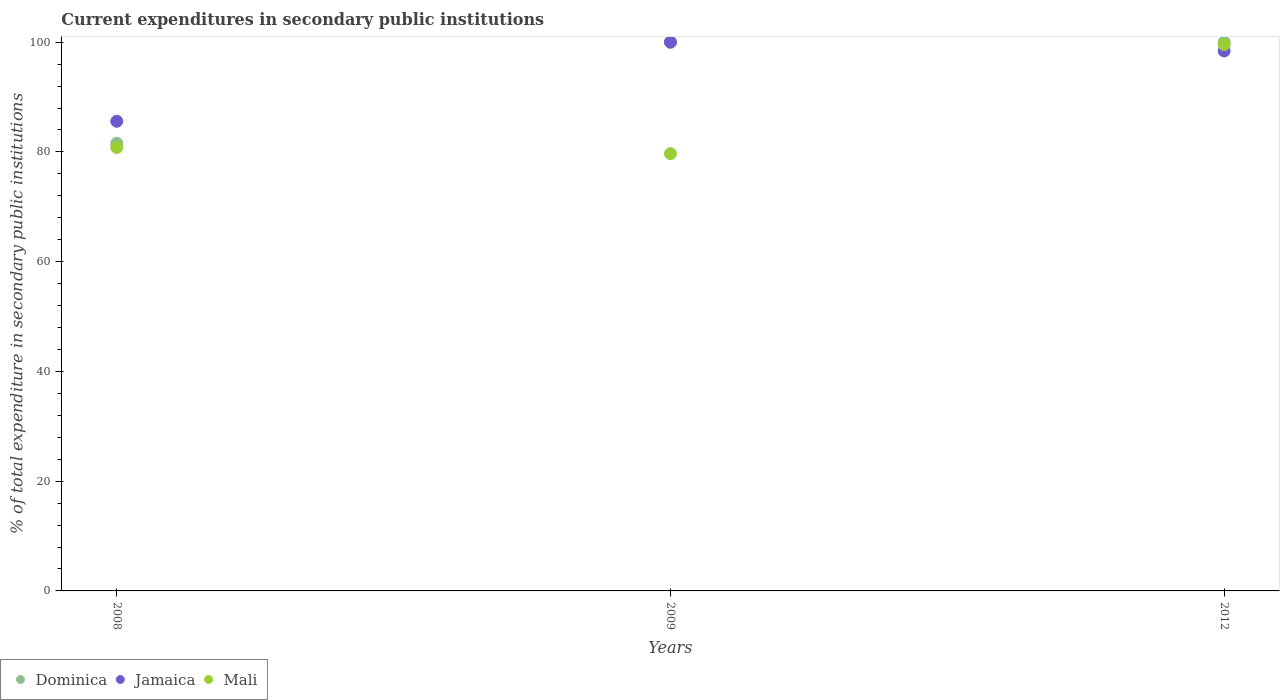What is the current expenditures in secondary public institutions in Jamaica in 2012?
Ensure brevity in your answer.  98.4. Across all years, what is the maximum current expenditures in secondary public institutions in Jamaica?
Ensure brevity in your answer.  100. Across all years, what is the minimum current expenditures in secondary public institutions in Jamaica?
Ensure brevity in your answer.  85.58. In which year was the current expenditures in secondary public institutions in Dominica maximum?
Offer a terse response. 2009. In which year was the current expenditures in secondary public institutions in Dominica minimum?
Offer a very short reply. 2008. What is the total current expenditures in secondary public institutions in Dominica in the graph?
Your answer should be very brief. 281.58. What is the difference between the current expenditures in secondary public institutions in Jamaica in 2008 and that in 2012?
Make the answer very short. -12.81. What is the difference between the current expenditures in secondary public institutions in Jamaica in 2012 and the current expenditures in secondary public institutions in Dominica in 2009?
Give a very brief answer. -1.6. What is the average current expenditures in secondary public institutions in Dominica per year?
Keep it short and to the point. 93.86. In the year 2008, what is the difference between the current expenditures in secondary public institutions in Mali and current expenditures in secondary public institutions in Dominica?
Provide a succinct answer. -0.77. What is the ratio of the current expenditures in secondary public institutions in Dominica in 2008 to that in 2012?
Keep it short and to the point. 0.82. Is the current expenditures in secondary public institutions in Mali in 2008 less than that in 2012?
Offer a terse response. Yes. What is the difference between the highest and the second highest current expenditures in secondary public institutions in Mali?
Provide a short and direct response. 18.75. What is the difference between the highest and the lowest current expenditures in secondary public institutions in Mali?
Make the answer very short. 19.87. Is the sum of the current expenditures in secondary public institutions in Jamaica in 2008 and 2012 greater than the maximum current expenditures in secondary public institutions in Dominica across all years?
Ensure brevity in your answer.  Yes. Is the current expenditures in secondary public institutions in Jamaica strictly greater than the current expenditures in secondary public institutions in Mali over the years?
Offer a very short reply. No. How many dotlines are there?
Your answer should be very brief. 3. How many years are there in the graph?
Your answer should be very brief. 3. Are the values on the major ticks of Y-axis written in scientific E-notation?
Ensure brevity in your answer.  No. Does the graph contain any zero values?
Offer a very short reply. No. Where does the legend appear in the graph?
Give a very brief answer. Bottom left. How are the legend labels stacked?
Offer a terse response. Horizontal. What is the title of the graph?
Provide a short and direct response. Current expenditures in secondary public institutions. Does "High income: nonOECD" appear as one of the legend labels in the graph?
Provide a short and direct response. No. What is the label or title of the Y-axis?
Give a very brief answer. % of total expenditure in secondary public institutions. What is the % of total expenditure in secondary public institutions in Dominica in 2008?
Keep it short and to the point. 81.58. What is the % of total expenditure in secondary public institutions of Jamaica in 2008?
Give a very brief answer. 85.58. What is the % of total expenditure in secondary public institutions of Mali in 2008?
Make the answer very short. 80.81. What is the % of total expenditure in secondary public institutions in Dominica in 2009?
Give a very brief answer. 100. What is the % of total expenditure in secondary public institutions in Mali in 2009?
Offer a terse response. 79.69. What is the % of total expenditure in secondary public institutions in Dominica in 2012?
Offer a very short reply. 100. What is the % of total expenditure in secondary public institutions in Jamaica in 2012?
Your response must be concise. 98.4. What is the % of total expenditure in secondary public institutions of Mali in 2012?
Provide a succinct answer. 99.55. Across all years, what is the maximum % of total expenditure in secondary public institutions in Mali?
Offer a very short reply. 99.55. Across all years, what is the minimum % of total expenditure in secondary public institutions in Dominica?
Your answer should be very brief. 81.58. Across all years, what is the minimum % of total expenditure in secondary public institutions of Jamaica?
Make the answer very short. 85.58. Across all years, what is the minimum % of total expenditure in secondary public institutions of Mali?
Keep it short and to the point. 79.69. What is the total % of total expenditure in secondary public institutions of Dominica in the graph?
Your answer should be very brief. 281.58. What is the total % of total expenditure in secondary public institutions of Jamaica in the graph?
Your answer should be very brief. 283.98. What is the total % of total expenditure in secondary public institutions of Mali in the graph?
Offer a very short reply. 260.05. What is the difference between the % of total expenditure in secondary public institutions in Dominica in 2008 and that in 2009?
Make the answer very short. -18.42. What is the difference between the % of total expenditure in secondary public institutions in Jamaica in 2008 and that in 2009?
Provide a succinct answer. -14.42. What is the difference between the % of total expenditure in secondary public institutions of Mali in 2008 and that in 2009?
Keep it short and to the point. 1.12. What is the difference between the % of total expenditure in secondary public institutions in Dominica in 2008 and that in 2012?
Offer a terse response. -18.42. What is the difference between the % of total expenditure in secondary public institutions in Jamaica in 2008 and that in 2012?
Keep it short and to the point. -12.81. What is the difference between the % of total expenditure in secondary public institutions of Mali in 2008 and that in 2012?
Your response must be concise. -18.75. What is the difference between the % of total expenditure in secondary public institutions in Jamaica in 2009 and that in 2012?
Your answer should be compact. 1.6. What is the difference between the % of total expenditure in secondary public institutions of Mali in 2009 and that in 2012?
Your response must be concise. -19.87. What is the difference between the % of total expenditure in secondary public institutions in Dominica in 2008 and the % of total expenditure in secondary public institutions in Jamaica in 2009?
Your answer should be very brief. -18.42. What is the difference between the % of total expenditure in secondary public institutions in Dominica in 2008 and the % of total expenditure in secondary public institutions in Mali in 2009?
Make the answer very short. 1.89. What is the difference between the % of total expenditure in secondary public institutions in Jamaica in 2008 and the % of total expenditure in secondary public institutions in Mali in 2009?
Give a very brief answer. 5.9. What is the difference between the % of total expenditure in secondary public institutions of Dominica in 2008 and the % of total expenditure in secondary public institutions of Jamaica in 2012?
Your response must be concise. -16.82. What is the difference between the % of total expenditure in secondary public institutions of Dominica in 2008 and the % of total expenditure in secondary public institutions of Mali in 2012?
Offer a very short reply. -17.97. What is the difference between the % of total expenditure in secondary public institutions in Jamaica in 2008 and the % of total expenditure in secondary public institutions in Mali in 2012?
Your answer should be very brief. -13.97. What is the difference between the % of total expenditure in secondary public institutions in Dominica in 2009 and the % of total expenditure in secondary public institutions in Jamaica in 2012?
Your response must be concise. 1.6. What is the difference between the % of total expenditure in secondary public institutions in Dominica in 2009 and the % of total expenditure in secondary public institutions in Mali in 2012?
Ensure brevity in your answer.  0.45. What is the difference between the % of total expenditure in secondary public institutions in Jamaica in 2009 and the % of total expenditure in secondary public institutions in Mali in 2012?
Your response must be concise. 0.45. What is the average % of total expenditure in secondary public institutions in Dominica per year?
Your response must be concise. 93.86. What is the average % of total expenditure in secondary public institutions of Jamaica per year?
Give a very brief answer. 94.66. What is the average % of total expenditure in secondary public institutions of Mali per year?
Make the answer very short. 86.68. In the year 2008, what is the difference between the % of total expenditure in secondary public institutions of Dominica and % of total expenditure in secondary public institutions of Jamaica?
Keep it short and to the point. -4. In the year 2008, what is the difference between the % of total expenditure in secondary public institutions of Dominica and % of total expenditure in secondary public institutions of Mali?
Keep it short and to the point. 0.77. In the year 2008, what is the difference between the % of total expenditure in secondary public institutions of Jamaica and % of total expenditure in secondary public institutions of Mali?
Offer a terse response. 4.78. In the year 2009, what is the difference between the % of total expenditure in secondary public institutions of Dominica and % of total expenditure in secondary public institutions of Jamaica?
Your answer should be compact. 0. In the year 2009, what is the difference between the % of total expenditure in secondary public institutions in Dominica and % of total expenditure in secondary public institutions in Mali?
Make the answer very short. 20.31. In the year 2009, what is the difference between the % of total expenditure in secondary public institutions of Jamaica and % of total expenditure in secondary public institutions of Mali?
Your answer should be compact. 20.31. In the year 2012, what is the difference between the % of total expenditure in secondary public institutions in Dominica and % of total expenditure in secondary public institutions in Jamaica?
Your response must be concise. 1.6. In the year 2012, what is the difference between the % of total expenditure in secondary public institutions of Dominica and % of total expenditure in secondary public institutions of Mali?
Make the answer very short. 0.45. In the year 2012, what is the difference between the % of total expenditure in secondary public institutions in Jamaica and % of total expenditure in secondary public institutions in Mali?
Make the answer very short. -1.16. What is the ratio of the % of total expenditure in secondary public institutions in Dominica in 2008 to that in 2009?
Provide a short and direct response. 0.82. What is the ratio of the % of total expenditure in secondary public institutions in Jamaica in 2008 to that in 2009?
Offer a terse response. 0.86. What is the ratio of the % of total expenditure in secondary public institutions of Mali in 2008 to that in 2009?
Ensure brevity in your answer.  1.01. What is the ratio of the % of total expenditure in secondary public institutions in Dominica in 2008 to that in 2012?
Keep it short and to the point. 0.82. What is the ratio of the % of total expenditure in secondary public institutions in Jamaica in 2008 to that in 2012?
Your answer should be very brief. 0.87. What is the ratio of the % of total expenditure in secondary public institutions in Mali in 2008 to that in 2012?
Offer a terse response. 0.81. What is the ratio of the % of total expenditure in secondary public institutions in Dominica in 2009 to that in 2012?
Your response must be concise. 1. What is the ratio of the % of total expenditure in secondary public institutions of Jamaica in 2009 to that in 2012?
Provide a short and direct response. 1.02. What is the ratio of the % of total expenditure in secondary public institutions of Mali in 2009 to that in 2012?
Keep it short and to the point. 0.8. What is the difference between the highest and the second highest % of total expenditure in secondary public institutions in Dominica?
Offer a very short reply. 0. What is the difference between the highest and the second highest % of total expenditure in secondary public institutions of Jamaica?
Your response must be concise. 1.6. What is the difference between the highest and the second highest % of total expenditure in secondary public institutions of Mali?
Make the answer very short. 18.75. What is the difference between the highest and the lowest % of total expenditure in secondary public institutions in Dominica?
Your answer should be compact. 18.42. What is the difference between the highest and the lowest % of total expenditure in secondary public institutions in Jamaica?
Ensure brevity in your answer.  14.42. What is the difference between the highest and the lowest % of total expenditure in secondary public institutions of Mali?
Provide a short and direct response. 19.87. 